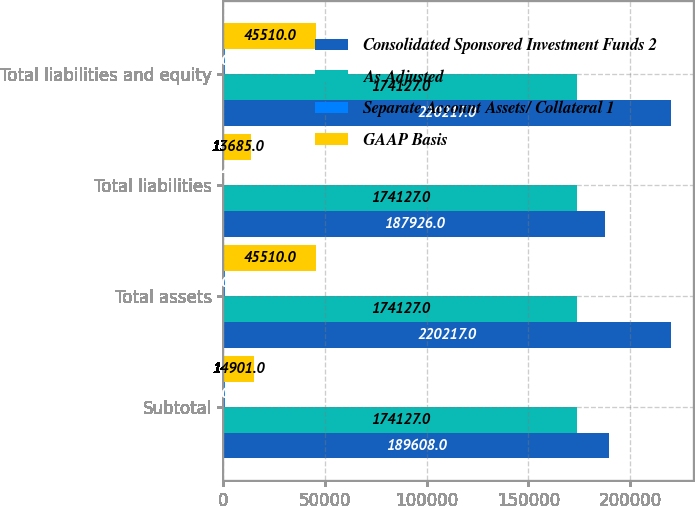Convert chart. <chart><loc_0><loc_0><loc_500><loc_500><stacked_bar_chart><ecel><fcel>Subtotal<fcel>Total assets<fcel>Total liabilities<fcel>Total liabilities and equity<nl><fcel>Consolidated Sponsored Investment Funds 2<fcel>189608<fcel>220217<fcel>187926<fcel>220217<nl><fcel>As Adjusted<fcel>174127<fcel>174127<fcel>174127<fcel>174127<nl><fcel>Separate Account Assets/ Collateral 1<fcel>580<fcel>580<fcel>114<fcel>580<nl><fcel>GAAP Basis<fcel>14901<fcel>45510<fcel>13685<fcel>45510<nl></chart> 